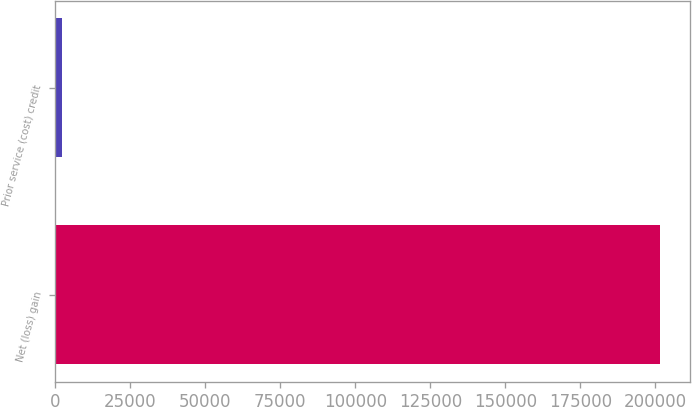Convert chart. <chart><loc_0><loc_0><loc_500><loc_500><bar_chart><fcel>Net (loss) gain<fcel>Prior service (cost) credit<nl><fcel>201578<fcel>2339<nl></chart> 